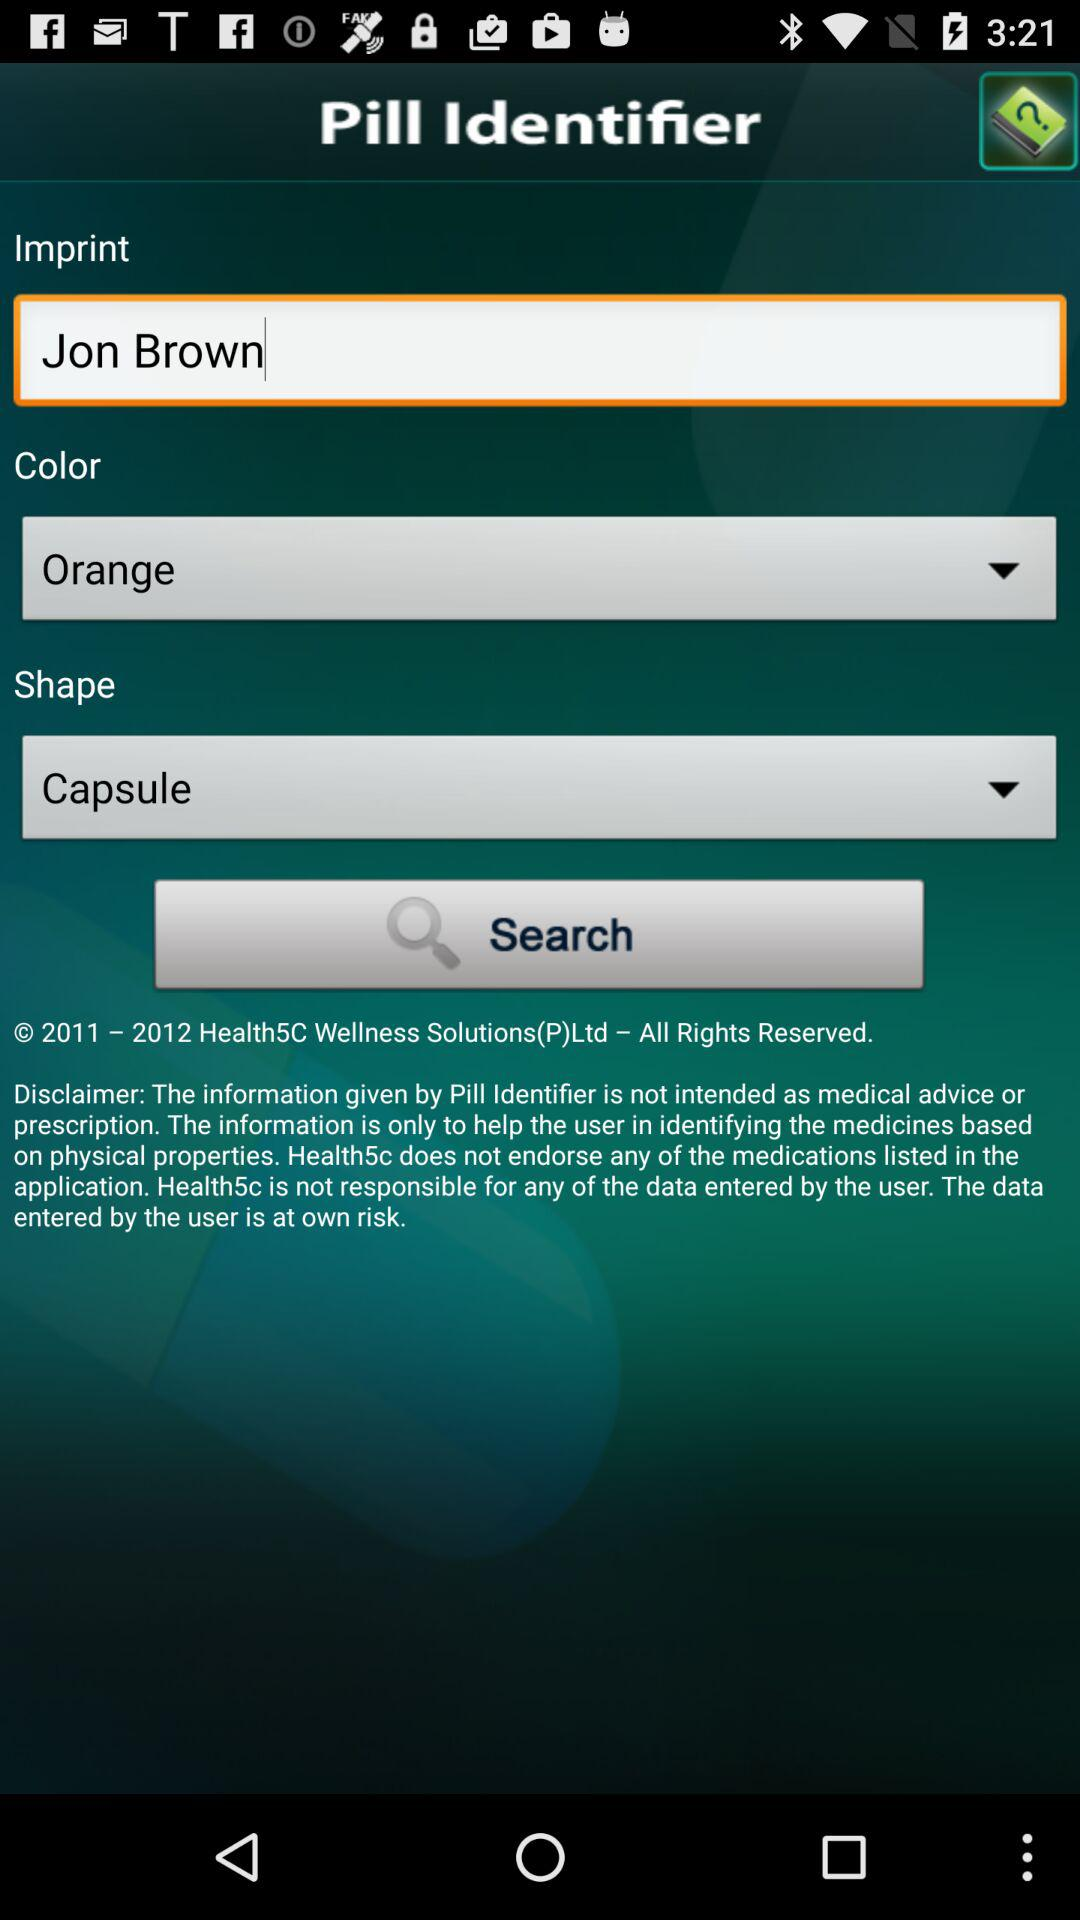Which shape is selected? The selected shape is "Capsule". 